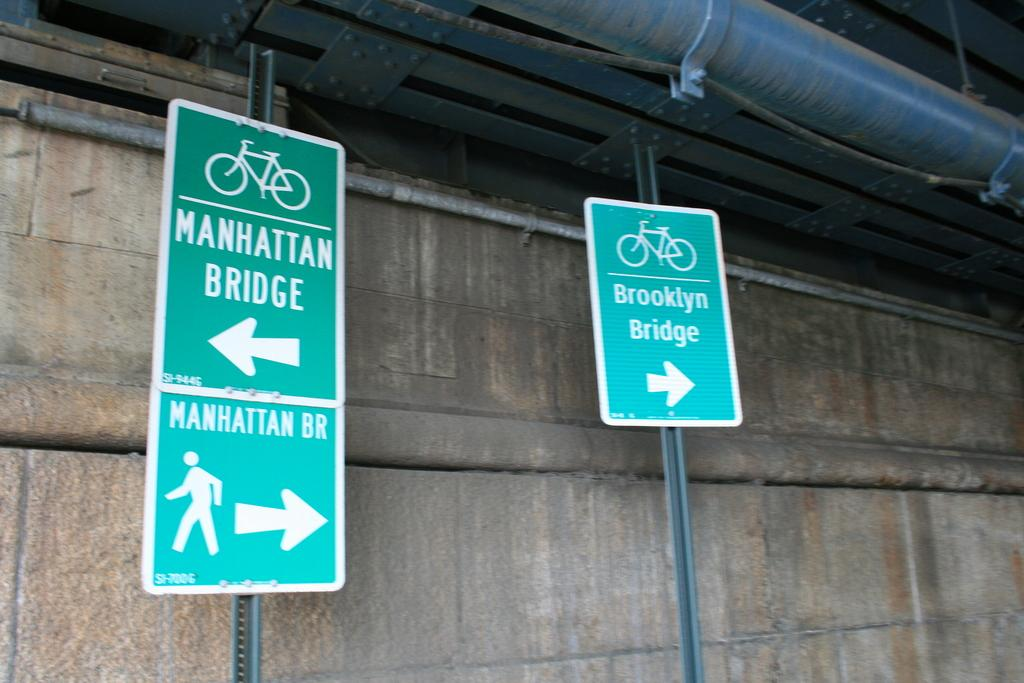<image>
Describe the image concisely. a sign reading brooklyn bridge sits on the right 